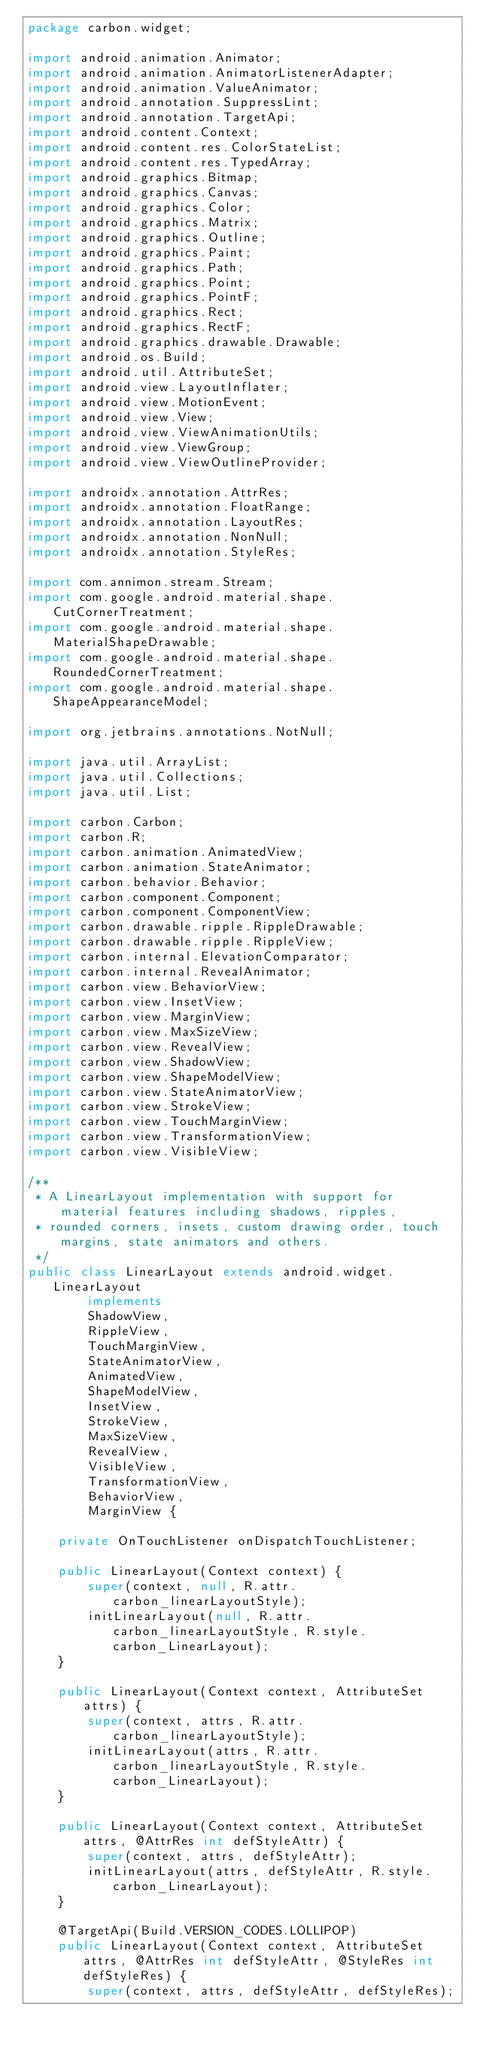<code> <loc_0><loc_0><loc_500><loc_500><_Java_>package carbon.widget;

import android.animation.Animator;
import android.animation.AnimatorListenerAdapter;
import android.animation.ValueAnimator;
import android.annotation.SuppressLint;
import android.annotation.TargetApi;
import android.content.Context;
import android.content.res.ColorStateList;
import android.content.res.TypedArray;
import android.graphics.Bitmap;
import android.graphics.Canvas;
import android.graphics.Color;
import android.graphics.Matrix;
import android.graphics.Outline;
import android.graphics.Paint;
import android.graphics.Path;
import android.graphics.Point;
import android.graphics.PointF;
import android.graphics.Rect;
import android.graphics.RectF;
import android.graphics.drawable.Drawable;
import android.os.Build;
import android.util.AttributeSet;
import android.view.LayoutInflater;
import android.view.MotionEvent;
import android.view.View;
import android.view.ViewAnimationUtils;
import android.view.ViewGroup;
import android.view.ViewOutlineProvider;

import androidx.annotation.AttrRes;
import androidx.annotation.FloatRange;
import androidx.annotation.LayoutRes;
import androidx.annotation.NonNull;
import androidx.annotation.StyleRes;

import com.annimon.stream.Stream;
import com.google.android.material.shape.CutCornerTreatment;
import com.google.android.material.shape.MaterialShapeDrawable;
import com.google.android.material.shape.RoundedCornerTreatment;
import com.google.android.material.shape.ShapeAppearanceModel;

import org.jetbrains.annotations.NotNull;

import java.util.ArrayList;
import java.util.Collections;
import java.util.List;

import carbon.Carbon;
import carbon.R;
import carbon.animation.AnimatedView;
import carbon.animation.StateAnimator;
import carbon.behavior.Behavior;
import carbon.component.Component;
import carbon.component.ComponentView;
import carbon.drawable.ripple.RippleDrawable;
import carbon.drawable.ripple.RippleView;
import carbon.internal.ElevationComparator;
import carbon.internal.RevealAnimator;
import carbon.view.BehaviorView;
import carbon.view.InsetView;
import carbon.view.MarginView;
import carbon.view.MaxSizeView;
import carbon.view.RevealView;
import carbon.view.ShadowView;
import carbon.view.ShapeModelView;
import carbon.view.StateAnimatorView;
import carbon.view.StrokeView;
import carbon.view.TouchMarginView;
import carbon.view.TransformationView;
import carbon.view.VisibleView;

/**
 * A LinearLayout implementation with support for material features including shadows, ripples,
 * rounded corners, insets, custom drawing order, touch margins, state animators and others.
 */
public class LinearLayout extends android.widget.LinearLayout
        implements
        ShadowView,
        RippleView,
        TouchMarginView,
        StateAnimatorView,
        AnimatedView,
        ShapeModelView,
        InsetView,
        StrokeView,
        MaxSizeView,
        RevealView,
        VisibleView,
        TransformationView,
        BehaviorView,
        MarginView {

    private OnTouchListener onDispatchTouchListener;

    public LinearLayout(Context context) {
        super(context, null, R.attr.carbon_linearLayoutStyle);
        initLinearLayout(null, R.attr.carbon_linearLayoutStyle, R.style.carbon_LinearLayout);
    }

    public LinearLayout(Context context, AttributeSet attrs) {
        super(context, attrs, R.attr.carbon_linearLayoutStyle);
        initLinearLayout(attrs, R.attr.carbon_linearLayoutStyle, R.style.carbon_LinearLayout);
    }

    public LinearLayout(Context context, AttributeSet attrs, @AttrRes int defStyleAttr) {
        super(context, attrs, defStyleAttr);
        initLinearLayout(attrs, defStyleAttr, R.style.carbon_LinearLayout);
    }

    @TargetApi(Build.VERSION_CODES.LOLLIPOP)
    public LinearLayout(Context context, AttributeSet attrs, @AttrRes int defStyleAttr, @StyleRes int defStyleRes) {
        super(context, attrs, defStyleAttr, defStyleRes);</code> 